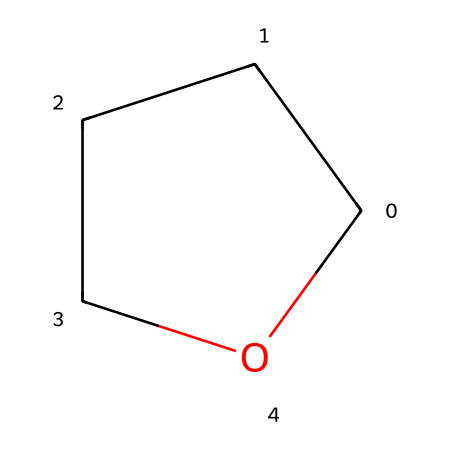What is the name of this chemical? The structure represented by the SMILES “C1CCCO1” corresponds to a five-membered ring with one oxygen atom and four carbon atoms, which is known as tetrahydrofuran.
Answer: tetrahydrofuran How many carbon atoms are in the chemical? The SMILES notation shows four carbon atoms (C) in the molecular structure, as there are four "C" notations within the ring.
Answer: four How many bonds are present in the structure? In tetrahydrofuran, there are two types of bonds; four carbon-carbon sigma bonds (C-C) and one oxygen-carbon bond (C-O), making a total of five bonds.
Answer: five What type of functional group is present in this compound? The presence of the oxygen atom within a ring structure signifies that this compound contains an ether functional group, specifically being cyclic, identifies it further as an ether.
Answer: ether Is tetrahydrofuran polar or non-polar? The oxygen atom creates a dipole moment in the molecule, making tetrahydrofuran a polar solvent, which allows it to dissolve various polar and ionic compounds effectively.
Answer: polar What is the main use of tetrahydrofuran in forensic analysis? Tetrahydrofuran is primarily utilized as a solvent in the extraction and analysis of various substances, including drugs during forensic investigations due to its ability to dissolve many organic compounds.
Answer: solvent 